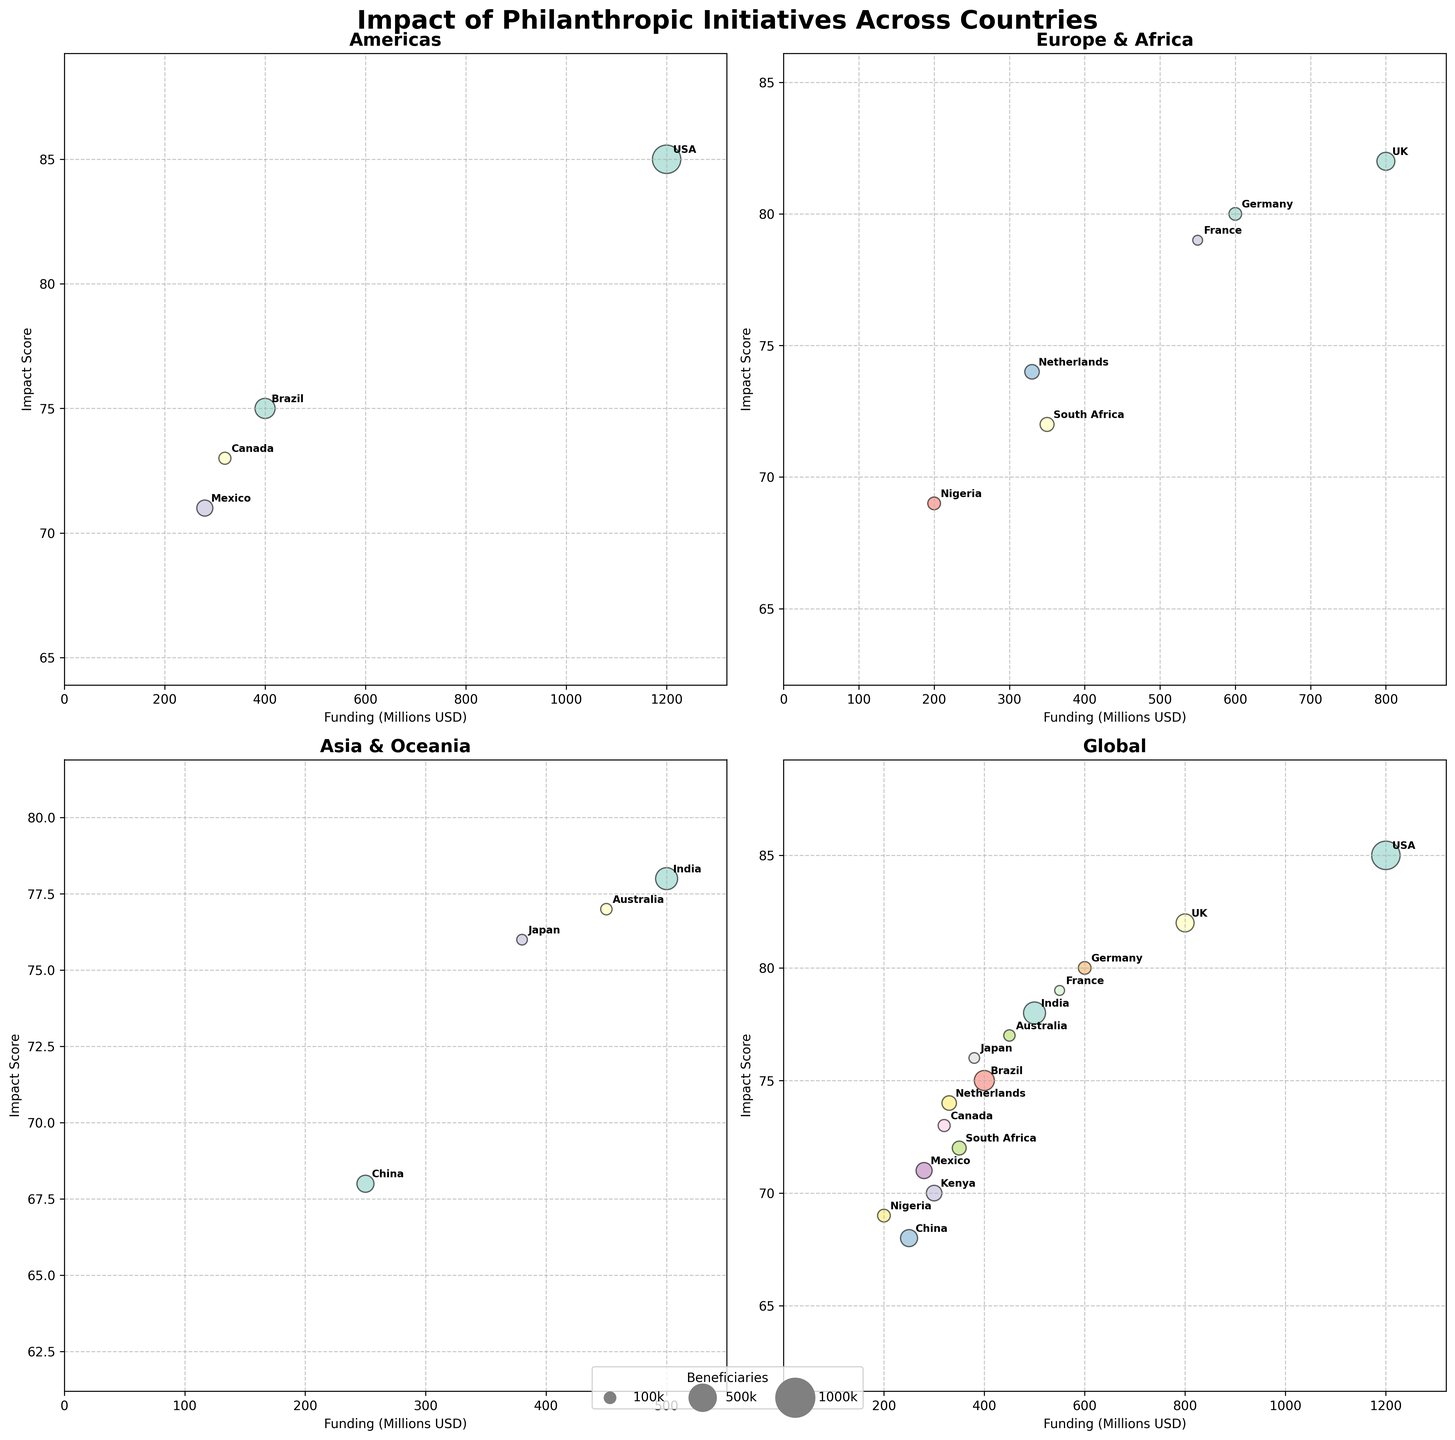How many countries are shown in the 'Americas' subplot? The 'Americas' subplot includes USA, Brazil, Canada, and Mexico based on the regions defined.
Answer: 4 Which initiative in the 'Asia & Oceania' region has the highest Impact Score? In the 'Asia & Oceania' subplot, India (Azim Premji Education Initiative) has the highest Impact Score of 78.
Answer: Azim Premji Education Initiative What is the range of Funding (Millions USD) in the 'Europe & Africa' subplot? The Funding (Millions USD) in 'Europe & Africa' ranges from Nigeria (200 Million USD) to UK (800 Million USD).
Answer: 200 - 800 Million USD Compare the number of beneficiaries between the initiatives in China and Australia. China (Jack Ma Rural Education Project) has 1800 thousand beneficiaries, whereas Australia (Minderoo Foundation Disaster Relief) has 800 thousand beneficiaries.
Answer: China has more beneficiaries Identify the country and initiative with the lowest Impact Score in the 'Global' region. The 'Global' region includes all countries. China (Jack Ma Rural Education Project) has the lowest Impact Score of 68.
Answer: China, Jack Ma Rural Education Project Which country in the 'Europe & Africa' region utilizes the highest Funding (Millions USD)? The UK (Wellcome Trust Medical Research) utilizes 800 Million USD, the highest in 'Europe & Africa'.
Answer: UK Calculate the average Impact Score of all initiatives in the 'Asia & Oceania' subplot. The Impact Scores for 'Asia & Oceania' are 78 (India) + 68 (China) + 77 (Australia) + 76 (Japan). The average is (78+68+77+76)/4 = 74.75.
Answer: 74.75 Which initiative in the 'Americas' has the maximum number of beneficiaries? The 'Americas' subplot includes USA (5000 thousand beneficiaries), Brazil (2500 thousand beneficiaries), Canada (900 thousand beneficiaries), and Mexico (1600 thousand beneficiaries). USA has the maximum.
Answer: USA, Gates Foundation Health Programs Between the initiatives in the 'Global' region, which has the highest Funding (Millions USD) but a lower Impact Score than Germany's initiative? Germany's (Bosch Foundation Climate Action) Impact Score is 80. France (Bettencourt Schueller Foundation Arts) has 550 Million USD funding with an Impact Score of 79, meeting both criteria.
Answer: France, Bettencourt Schueller Foundation Arts In the 'Asia & Oceania' region, which initiatives have a higher Impact Score than the average for that region? The average Impact Score for 'Asia & Oceania' is 74.75. Initiatives in India (78), Australia (77), and Japan (76) have higher scores than the average.
Answer: India, Australia, Japan 